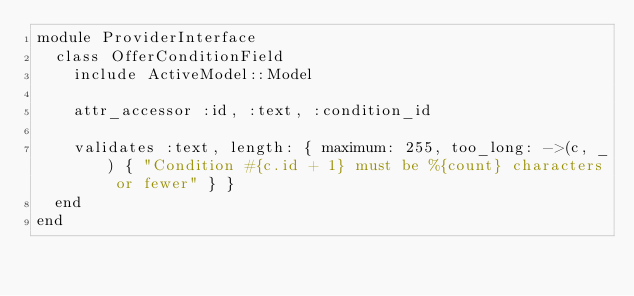<code> <loc_0><loc_0><loc_500><loc_500><_Ruby_>module ProviderInterface
  class OfferConditionField
    include ActiveModel::Model

    attr_accessor :id, :text, :condition_id

    validates :text, length: { maximum: 255, too_long: ->(c, _) { "Condition #{c.id + 1} must be %{count} characters or fewer" } }
  end
end
</code> 